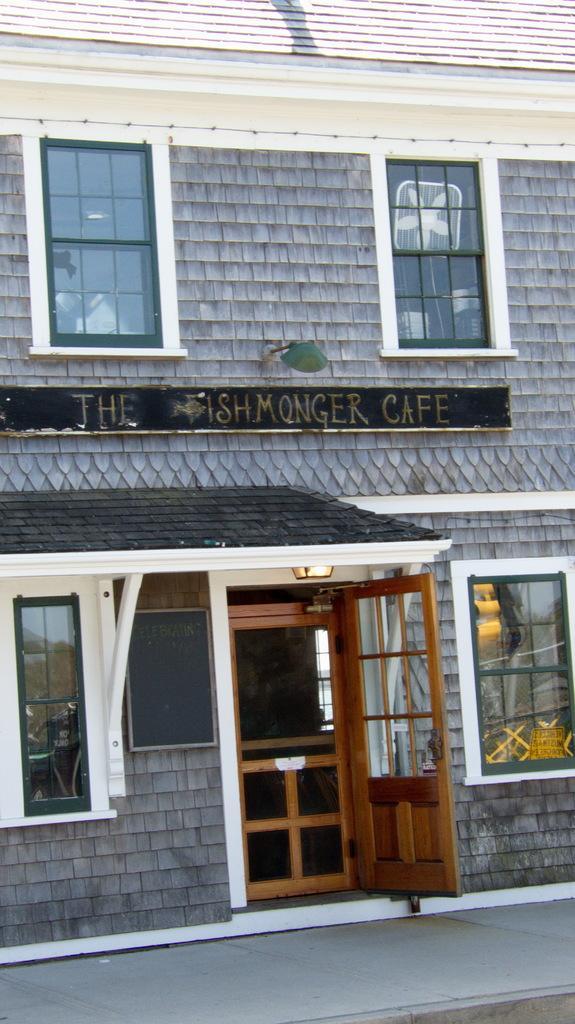How would you summarize this image in a sentence or two? In this picture I can see the wooden door. I can see glass windows. I can see the house. I can see light arrangement on the roof. 